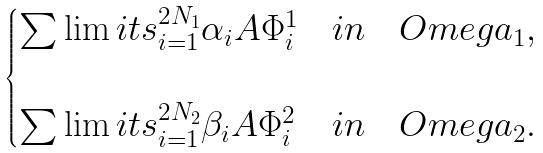<formula> <loc_0><loc_0><loc_500><loc_500>\begin{cases} \sum \lim i t s _ { i = 1 } ^ { 2 N _ { 1 } } \alpha _ { i } A \Phi ^ { 1 } _ { i } & i n \quad O m e g a _ { 1 } , \\ \\ \sum \lim i t s _ { i = 1 } ^ { 2 N _ { 2 } } \beta _ { i } A \Phi ^ { 2 } _ { i } & i n \quad O m e g a _ { 2 } . \\ \end{cases}</formula> 